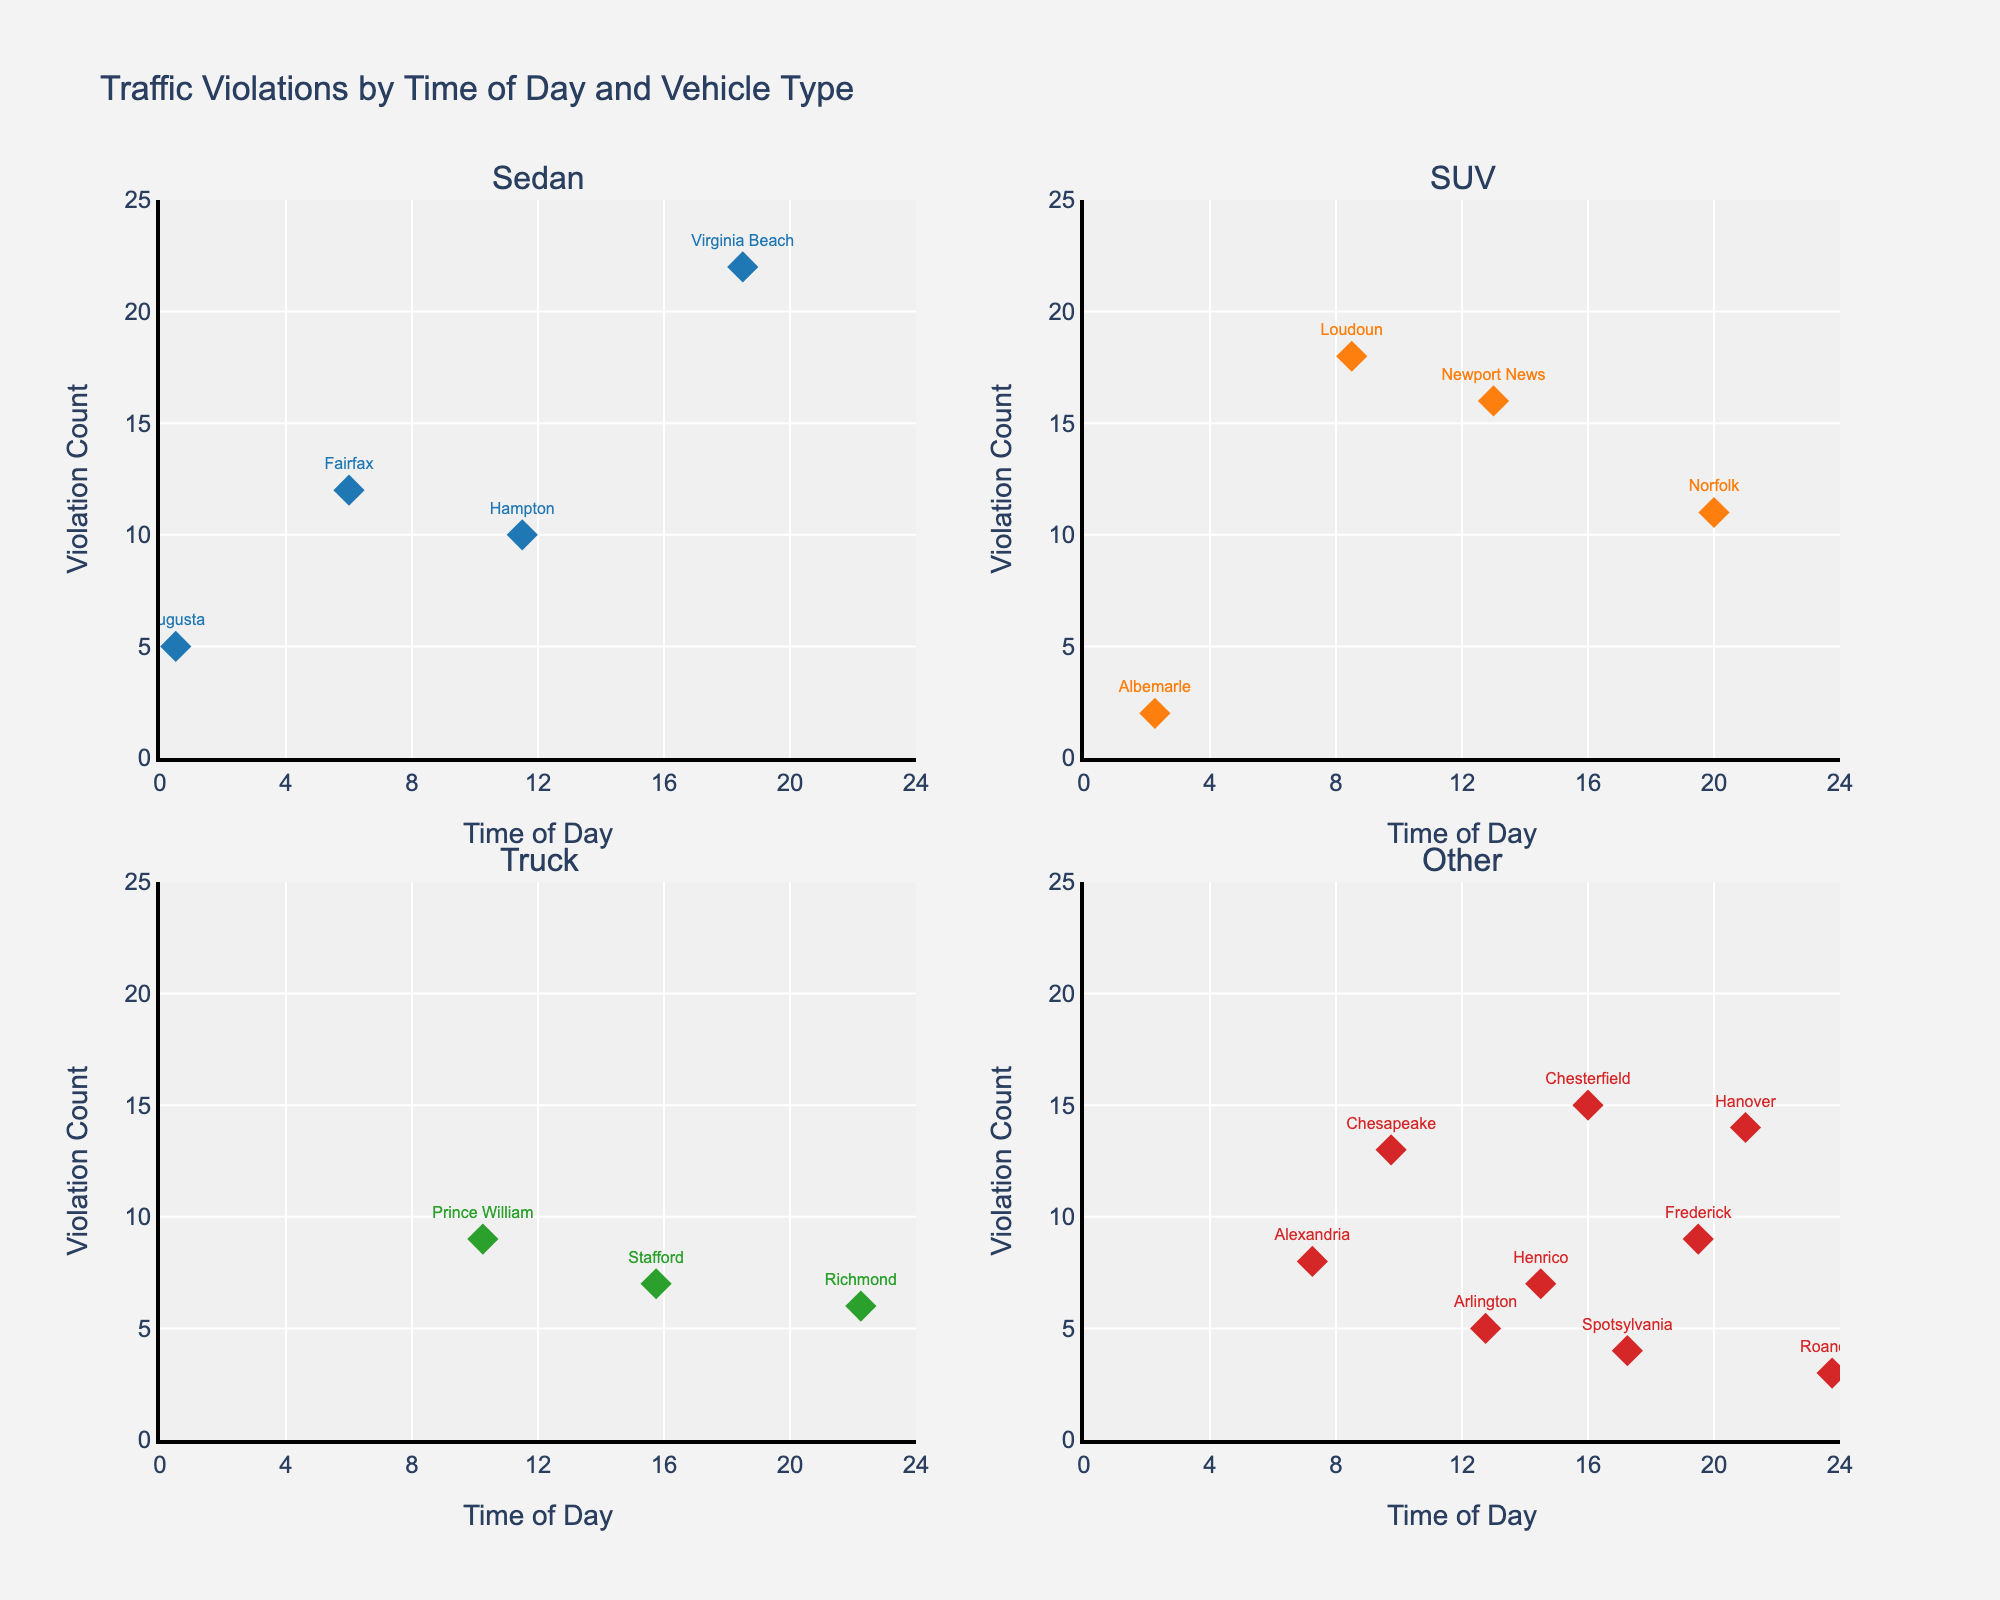what is the title of the figure? The title is generally located at the top of the figure and often summarizes the main idea represented. In the case of this figure, it is "Traffic Violations by Time of Day and Vehicle Type".
Answer: Traffic Violations by Time of Day and Vehicle Type how many subplots are there in the figure? Each section of the figure separated by lines indicates a subplot. In this case, there are four subplots: one for Sedans, one for SUVs, one for Trucks, and one for Other vehicle types.
Answer: 4 what is the range of the x-axis? The x-axis represents 'Time of Day,' which is standardized across all subplots. According to the settings in the figure, the range is from 0 to 24 hours.
Answer: 0 to 24 which vehicle type has the highest single count of violations, and what is its value? By looking at the y-axis and the height of the markers, you can see that the Sedan type has a marker at 22 violations, which is the highest count in this figure.
Answer: Sedan, 22 which county and vehicle type had traffic violations at 10:15, and how many violations were there? Cross-referencing the time on the x-axis and the text labels for the markers at 10:15, you find that Prince William county with a Truck had 9 violations.
Answer: Prince William, Truck, 9 which vehicle types had violations before 6:00 am, and what were the violation counts? Checking the x-axis values earlier than 6:00, you find data points for Sedans (5 violations) and SUVs (2 violations).
Answer: Sedan, 5; SUV, 2 how do the Sedan and SUV vehicle types compare in terms of their earliest violation times? The earliest time for Sedan and SUV data points can be checked on the x-axis; Sedans start at 6:00, while SUVs have an earlier point at 2:15.
Answer: SUV violations occur earlier than Sedan what is the total number of violations for vehicles categorized as "Other"? The subplot for "Other" contains data points for Motorcycle, Van, and Pickup truck types. Summing up their violation counts (Motorcycle: 5+3+4=12, Van: 7+8+9=24, Pickup: 15+13+14=42) in the respective subplot, the total is 12+24+42.
Answer: 78 between which hours does the highest concentration of violations occur for Trucks? By examining the subplot for Trucks and looking for clustered markers, the concentration of points around the afternoon hours especially show high violations between 12:00 - 18:00.
Answer: 12:00 - 18:00 how many counties reported zero violations in any particular vehicle type? Checking for the lack of any markers (data points) in each subplot for certain vehicle types across counties, no county is entirely missing in the figure, hence indicating zero violations for any vehicle type.
Answer: 0 